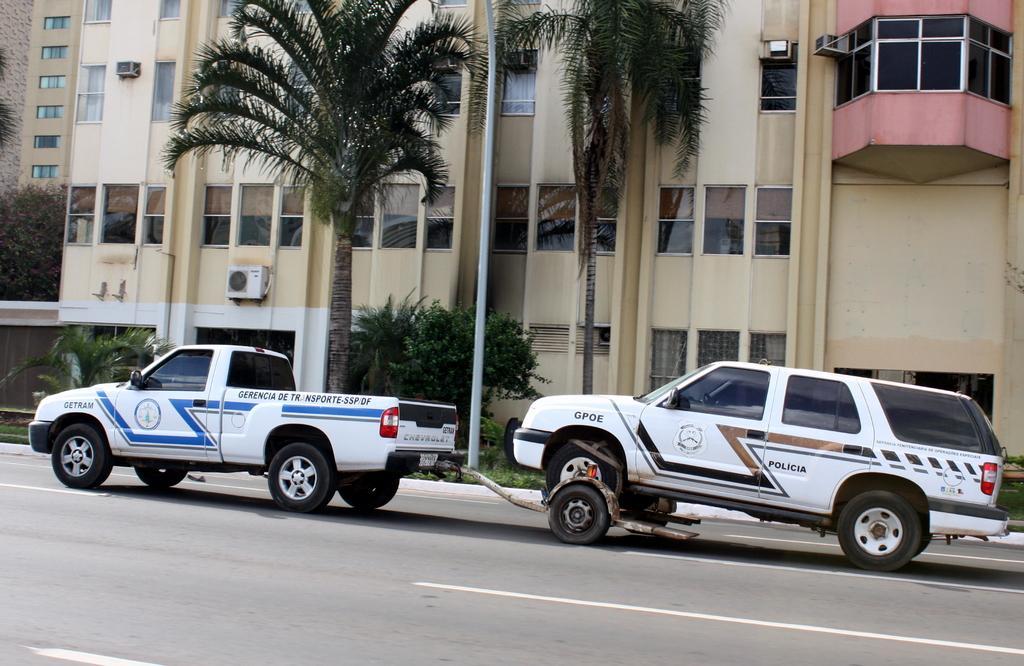In one or two sentences, can you explain what this image depicts? In the image there is a truck and a vehicle are attached to each other and behind those vehicles there are some trees and behind the trees there is a huge building. 